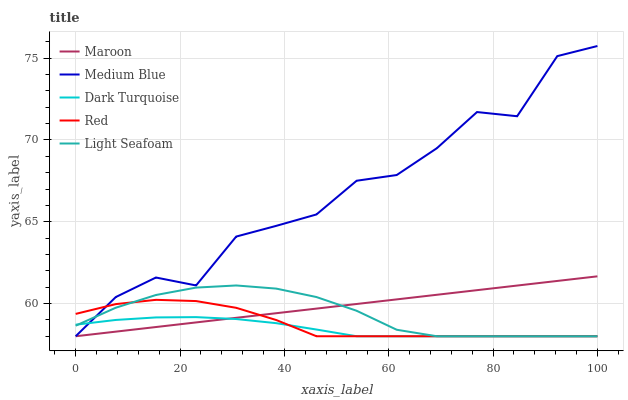Does Dark Turquoise have the minimum area under the curve?
Answer yes or no. Yes. Does Medium Blue have the maximum area under the curve?
Answer yes or no. Yes. Does Light Seafoam have the minimum area under the curve?
Answer yes or no. No. Does Light Seafoam have the maximum area under the curve?
Answer yes or no. No. Is Maroon the smoothest?
Answer yes or no. Yes. Is Medium Blue the roughest?
Answer yes or no. Yes. Is Light Seafoam the smoothest?
Answer yes or no. No. Is Light Seafoam the roughest?
Answer yes or no. No. Does Dark Turquoise have the lowest value?
Answer yes or no. Yes. Does Medium Blue have the highest value?
Answer yes or no. Yes. Does Light Seafoam have the highest value?
Answer yes or no. No. Does Maroon intersect Medium Blue?
Answer yes or no. Yes. Is Maroon less than Medium Blue?
Answer yes or no. No. Is Maroon greater than Medium Blue?
Answer yes or no. No. 